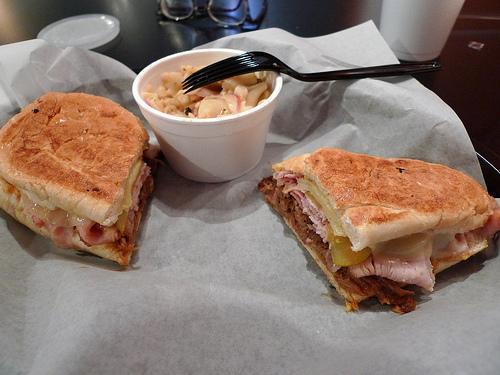How many sandwich sections are visible?
Give a very brief answer. 2. 